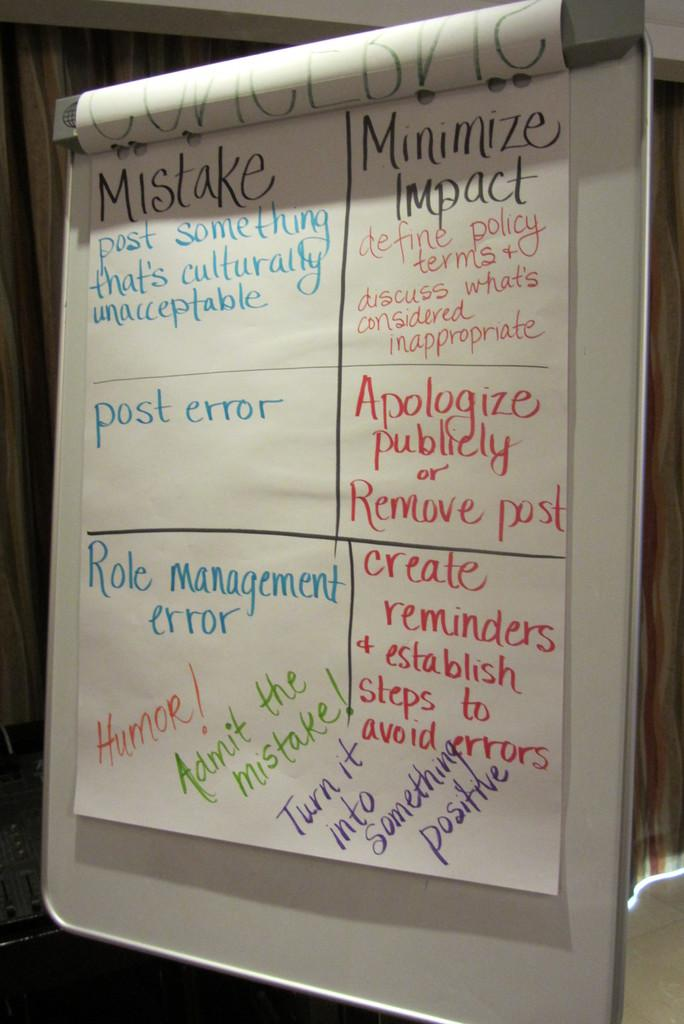Provide a one-sentence caption for the provided image. A poster describing proper procedures when an error happens. 